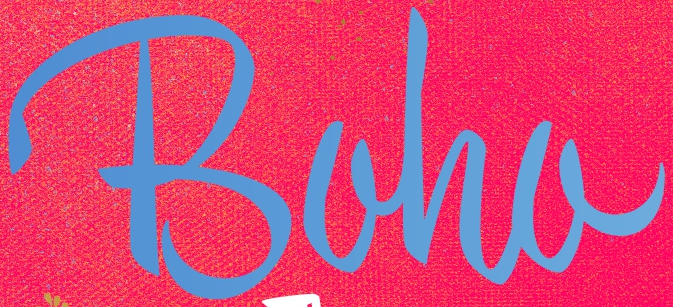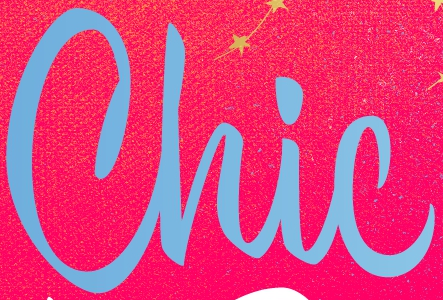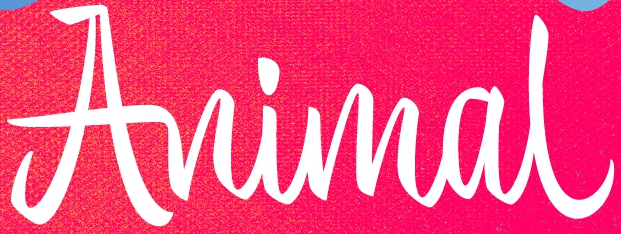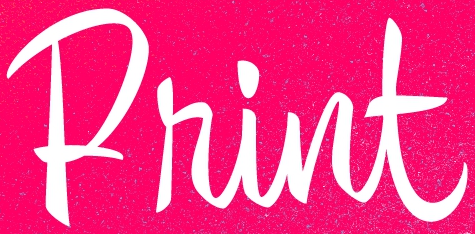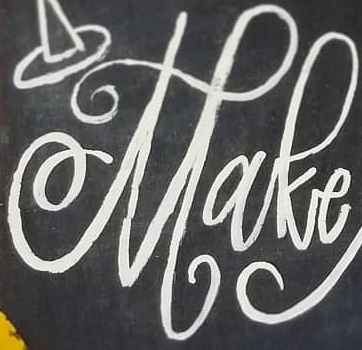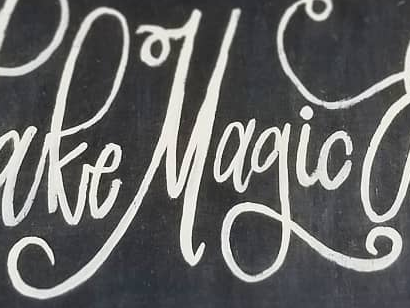What words can you see in these images in sequence, separated by a semicolon? Boha; Chic; Animal; Print; Make; Magic 